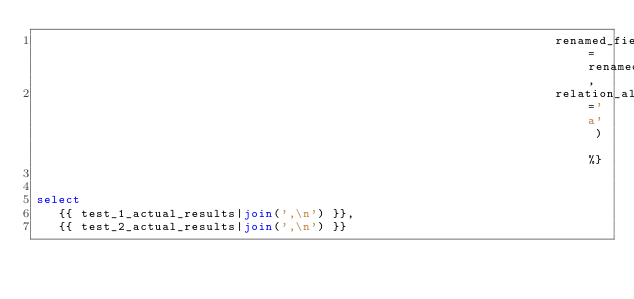Convert code to text. <code><loc_0><loc_0><loc_500><loc_500><_SQL_>                                                                      renamed_fields=renamed_fields,
                                                                      relation_alias='a' ) %}


select
   {{ test_1_actual_results|join(',\n') }},
   {{ test_2_actual_results|join(',\n') }}
</code> 